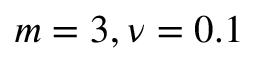<formula> <loc_0><loc_0><loc_500><loc_500>m = 3 , \nu = 0 . 1</formula> 